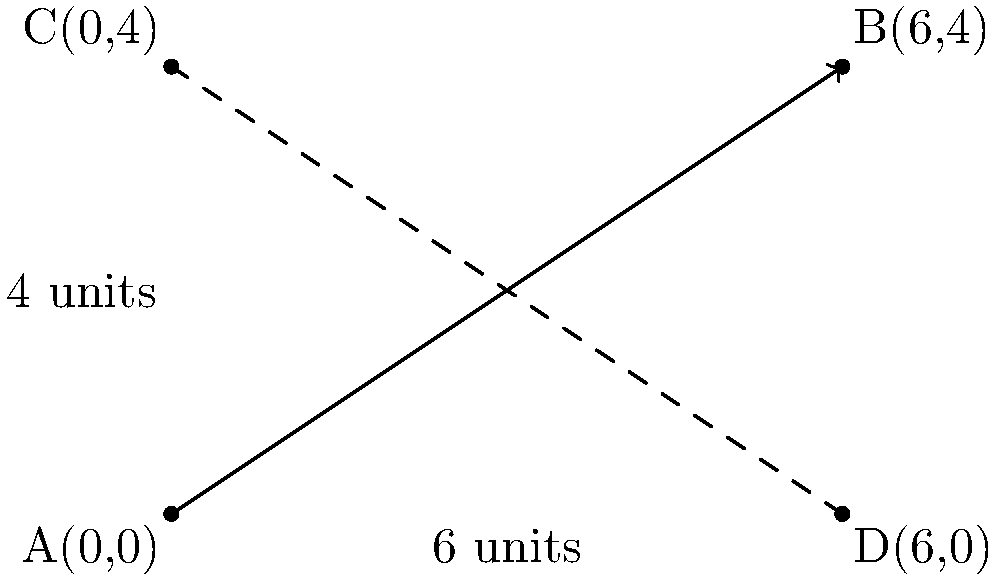In a screen-printed design for a diagonal stripe pattern, you want to create a line that passes through points A(0,0) and B(6,4) on your fabric. What is the slope of this line, which will determine the angle of your diagonal stripes? To find the slope of the line passing through points A(0,0) and B(6,4), we can use the slope formula:

$$ \text{Slope} = m = \frac{y_2 - y_1}{x_2 - x_1} $$

Where $(x_1, y_1)$ are the coordinates of point A, and $(x_2, y_2)$ are the coordinates of point B.

Step 1: Identify the coordinates
A: $(x_1, y_1) = (0, 0)$
B: $(x_2, y_2) = (6, 4)$

Step 2: Apply the slope formula
$$ m = \frac{y_2 - y_1}{x_2 - x_1} = \frac{4 - 0}{6 - 0} = \frac{4}{6} $$

Step 3: Simplify the fraction
$$ m = \frac{4}{6} = \frac{2}{3} $$

Therefore, the slope of the line is $\frac{2}{3}$ or approximately 0.667. This means that for every 3 units the line moves horizontally, it rises 2 units vertically, creating a diagonal stripe pattern with this specific angle.
Answer: $\frac{2}{3}$ 